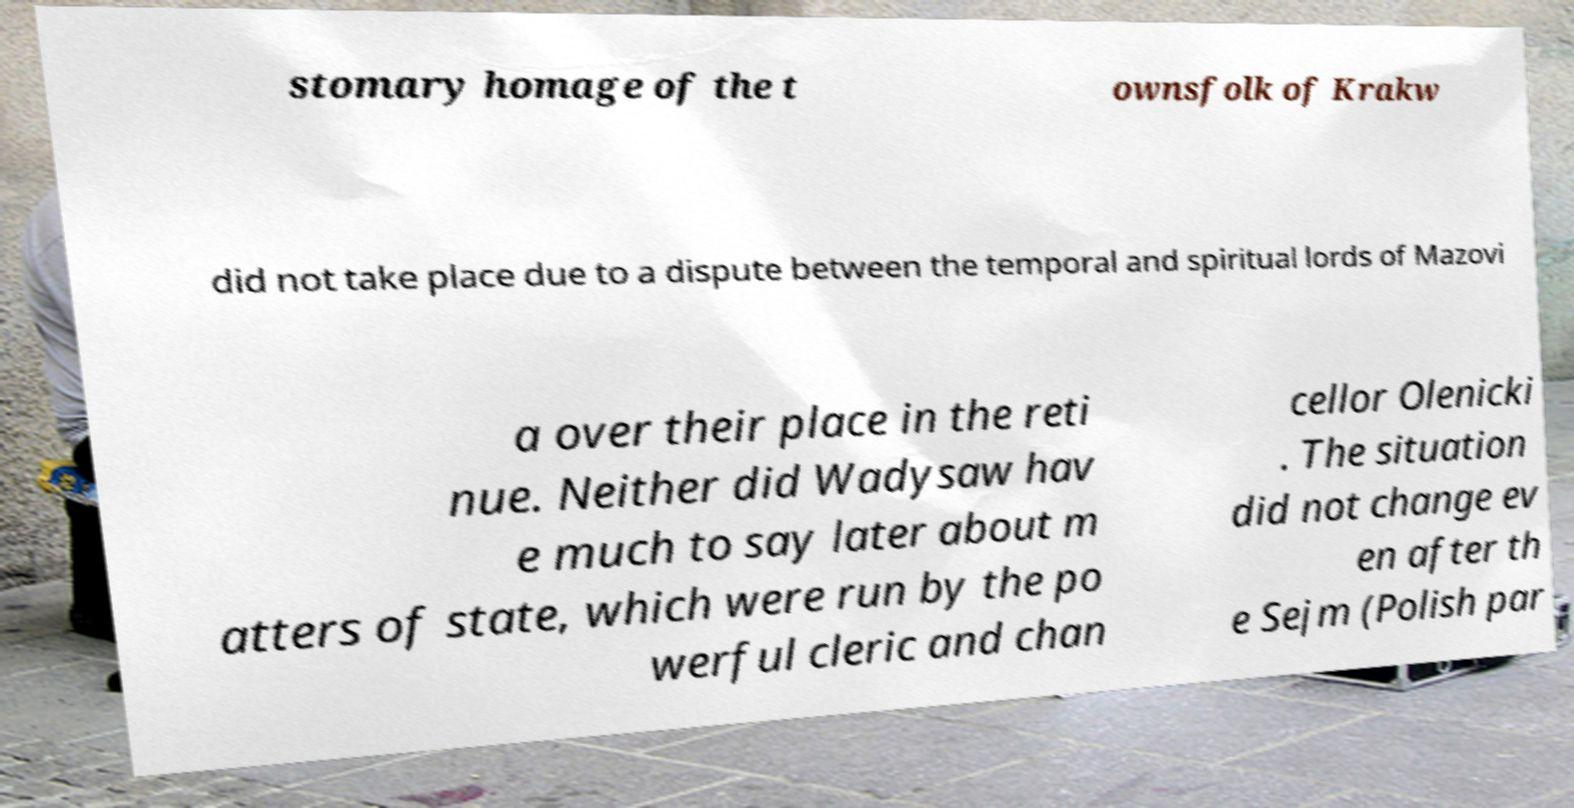Please identify and transcribe the text found in this image. stomary homage of the t ownsfolk of Krakw did not take place due to a dispute between the temporal and spiritual lords of Mazovi a over their place in the reti nue. Neither did Wadysaw hav e much to say later about m atters of state, which were run by the po werful cleric and chan cellor Olenicki . The situation did not change ev en after th e Sejm (Polish par 